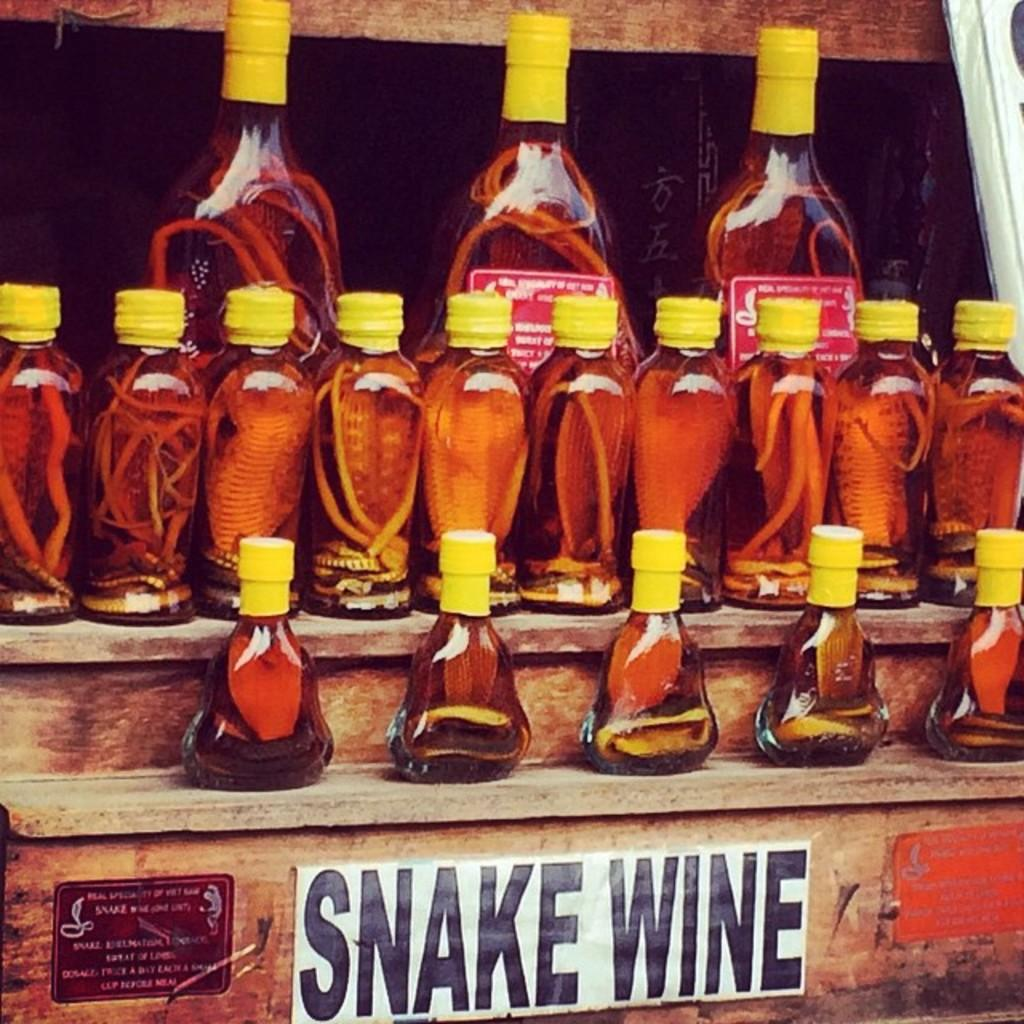<image>
Create a compact narrative representing the image presented. A bunch of irregular bottles full of Snake Wine. 